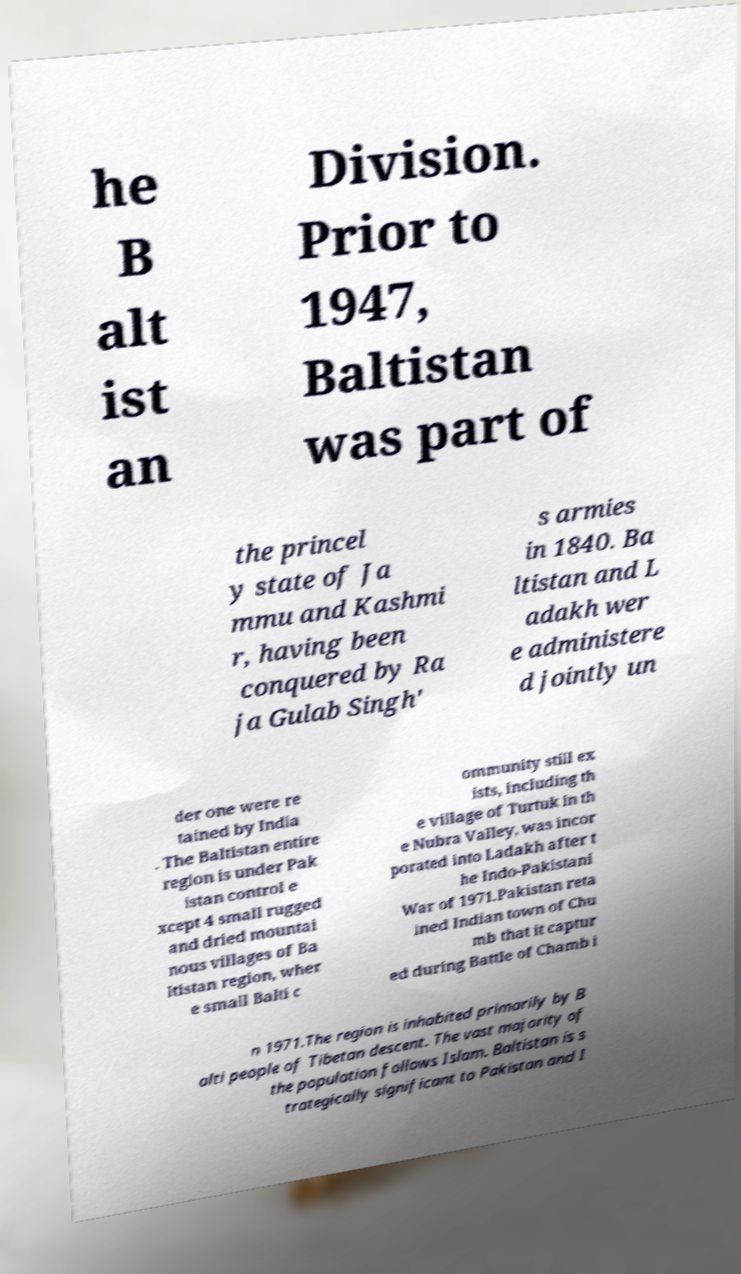Please read and relay the text visible in this image. What does it say? he B alt ist an Division. Prior to 1947, Baltistan was part of the princel y state of Ja mmu and Kashmi r, having been conquered by Ra ja Gulab Singh' s armies in 1840. Ba ltistan and L adakh wer e administere d jointly un der one were re tained by India . The Baltistan entire region is under Pak istan control e xcept 4 small rugged and dried mountai nous villages of Ba ltistan region, wher e small Balti c ommunity still ex ists, including th e village of Turtuk in th e Nubra Valley, was incor porated into Ladakh after t he Indo-Pakistani War of 1971.Pakistan reta ined Indian town of Chu mb that it captur ed during Battle of Chamb i n 1971.The region is inhabited primarily by B alti people of Tibetan descent. The vast majority of the population follows Islam. Baltistan is s trategically significant to Pakistan and I 